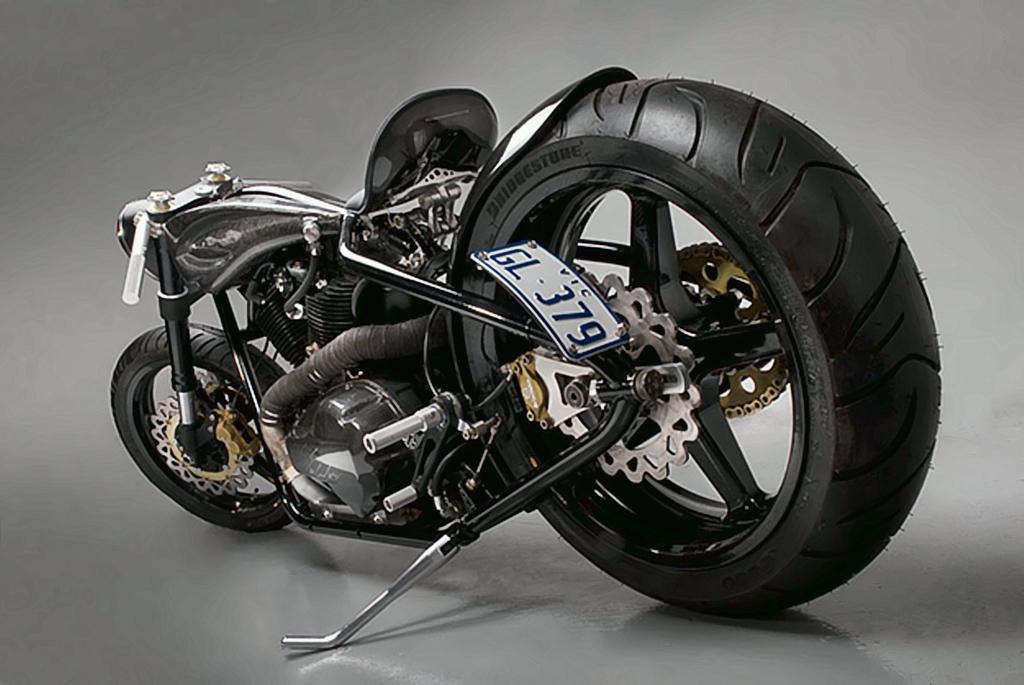Could you give a brief overview of what you see in this image? In the center of the image, we can see a motorbike on the floor. 